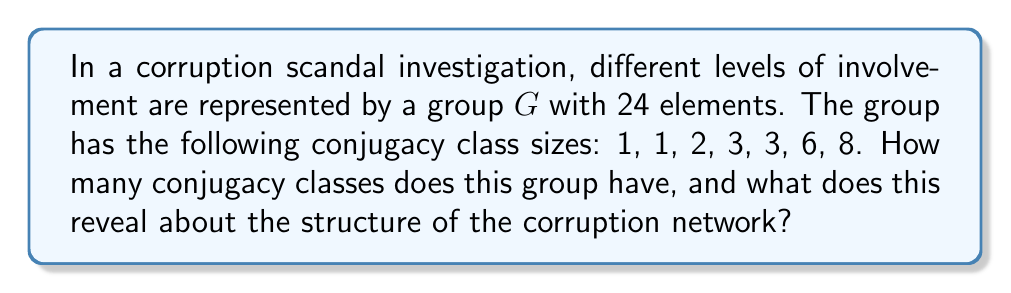Can you answer this question? To solve this problem, we need to understand the concept of conjugacy classes in group theory and how it relates to our corruption scandal investigation:

1. Conjugacy classes: In group theory, two elements $a$ and $b$ of a group $G$ are conjugate if there exists an element $g \in G$ such that $gag^{-1} = b$. The set of all elements conjugate to an element $a$ is called its conjugacy class.

2. Properties of conjugacy classes:
   - Conjugacy classes partition the group into disjoint subsets.
   - The number of conjugacy classes is equal to the number of irreducible representations of the group.
   - The sum of the sizes of all conjugacy classes must equal the order of the group.

3. Given information:
   - Group $G$ has 24 elements (order of the group).
   - Conjugacy class sizes: 1, 1, 2, 3, 3, 6, 8

4. Counting conjugacy classes:
   To find the number of conjugacy classes, we simply need to count the number of given class sizes.
   Number of conjugacy classes = 7

5. Verifying the result:
   We can check if the sum of all class sizes equals the order of the group:
   $$1 + 1 + 2 + 3 + 3 + 6 + 8 = 24$$
   This confirms our count is correct.

6. Interpretation for the corruption network:
   - Each conjugacy class represents a distinct level or type of involvement in the scandal.
   - The number of conjugacy classes (7) indicates the number of different roles or levels of involvement in the corruption network.
   - The sizes of the conjugacy classes suggest the relative frequency of each role:
     * Two classes of size 1: Likely represent unique positions (e.g., ringleaders)
     * One class of size 2: A rare but not unique position
     * Two classes of size 3: Two different roles with equal frequency
     * One class of size 6: A more common role in the network
     * One class of size 8: The most common type of involvement

This analysis provides insights into the structure and hierarchy of the corruption network, which could be valuable for the journalistic investigation.
Answer: The group has 7 conjugacy classes, revealing 7 distinct levels or types of involvement in the corruption network, ranging from unique leadership positions to more common roles. 